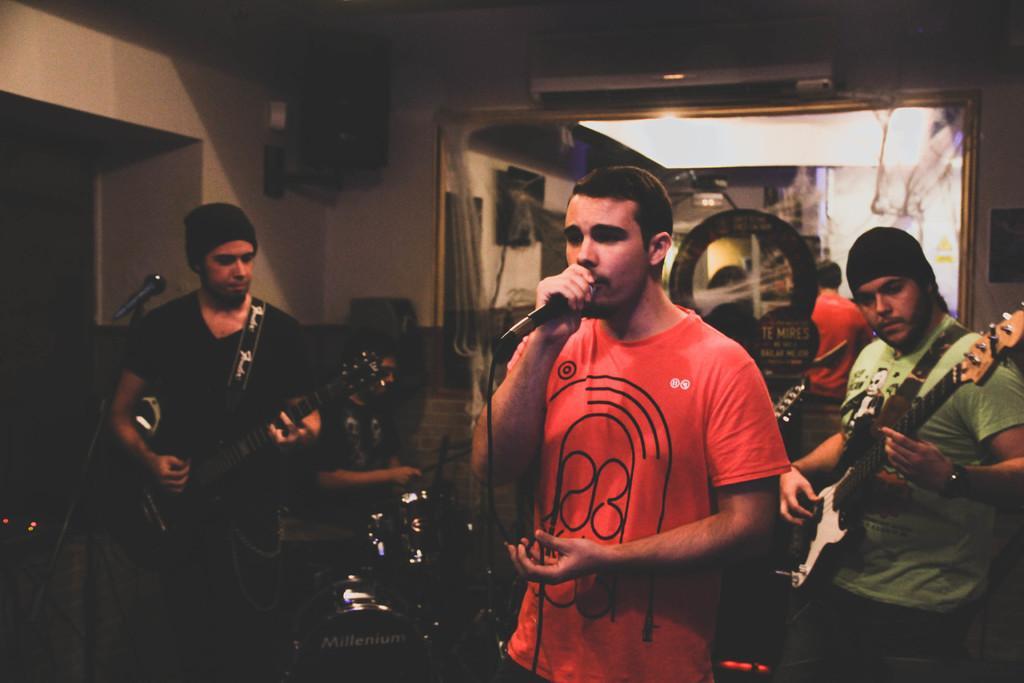Describe this image in one or two sentences. There are four persons. The three persons are standing. They are playing a musical instruments. In the center of the person is holding a mic and he is singing a song. On the left side of the person is sitting on a chair. He is playing musical instruments. We can see in the background wall,sound box ,AC,mirror. 